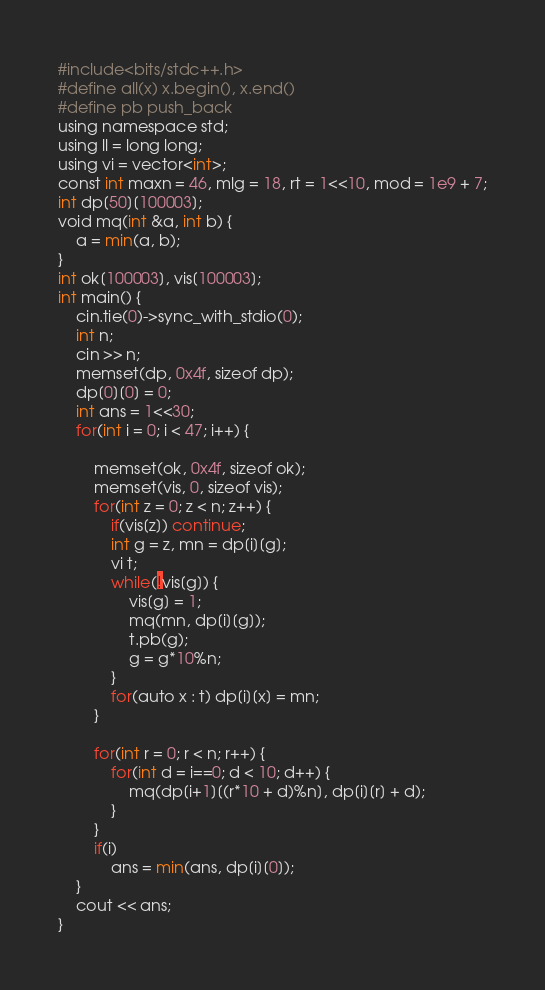<code> <loc_0><loc_0><loc_500><loc_500><_Python_>#include<bits/stdc++.h>
#define all(x) x.begin(), x.end()
#define pb push_back
using namespace std;
using ll = long long;
using vi = vector<int>;
const int maxn = 46, mlg = 18, rt = 1<<10, mod = 1e9 + 7;
int dp[50][100003];
void mq(int &a, int b) {
	a = min(a, b);
}
int ok[100003], vis[100003];
int main() {
	cin.tie(0)->sync_with_stdio(0);
	int n;
	cin >> n;
	memset(dp, 0x4f, sizeof dp);
	dp[0][0] = 0;
	int ans = 1<<30;
	for(int i = 0; i < 47; i++) {
		
		memset(ok, 0x4f, sizeof ok);
		memset(vis, 0, sizeof vis);
		for(int z = 0; z < n; z++) {
			if(vis[z]) continue;
			int g = z, mn = dp[i][g];
			vi t;
			while(!vis[g]) {
				vis[g] = 1;
				mq(mn, dp[i][g]);
				t.pb(g);
				g = g*10%n;
			}
			for(auto x : t) dp[i][x] = mn;
		}
		
		for(int r = 0; r < n; r++) {
			for(int d = i==0; d < 10; d++) {
				mq(dp[i+1][(r*10 + d)%n], dp[i][r] + d);
			}
		}
		if(i)
			ans = min(ans, dp[i][0]);
	}
	cout << ans;
} 
</code> 